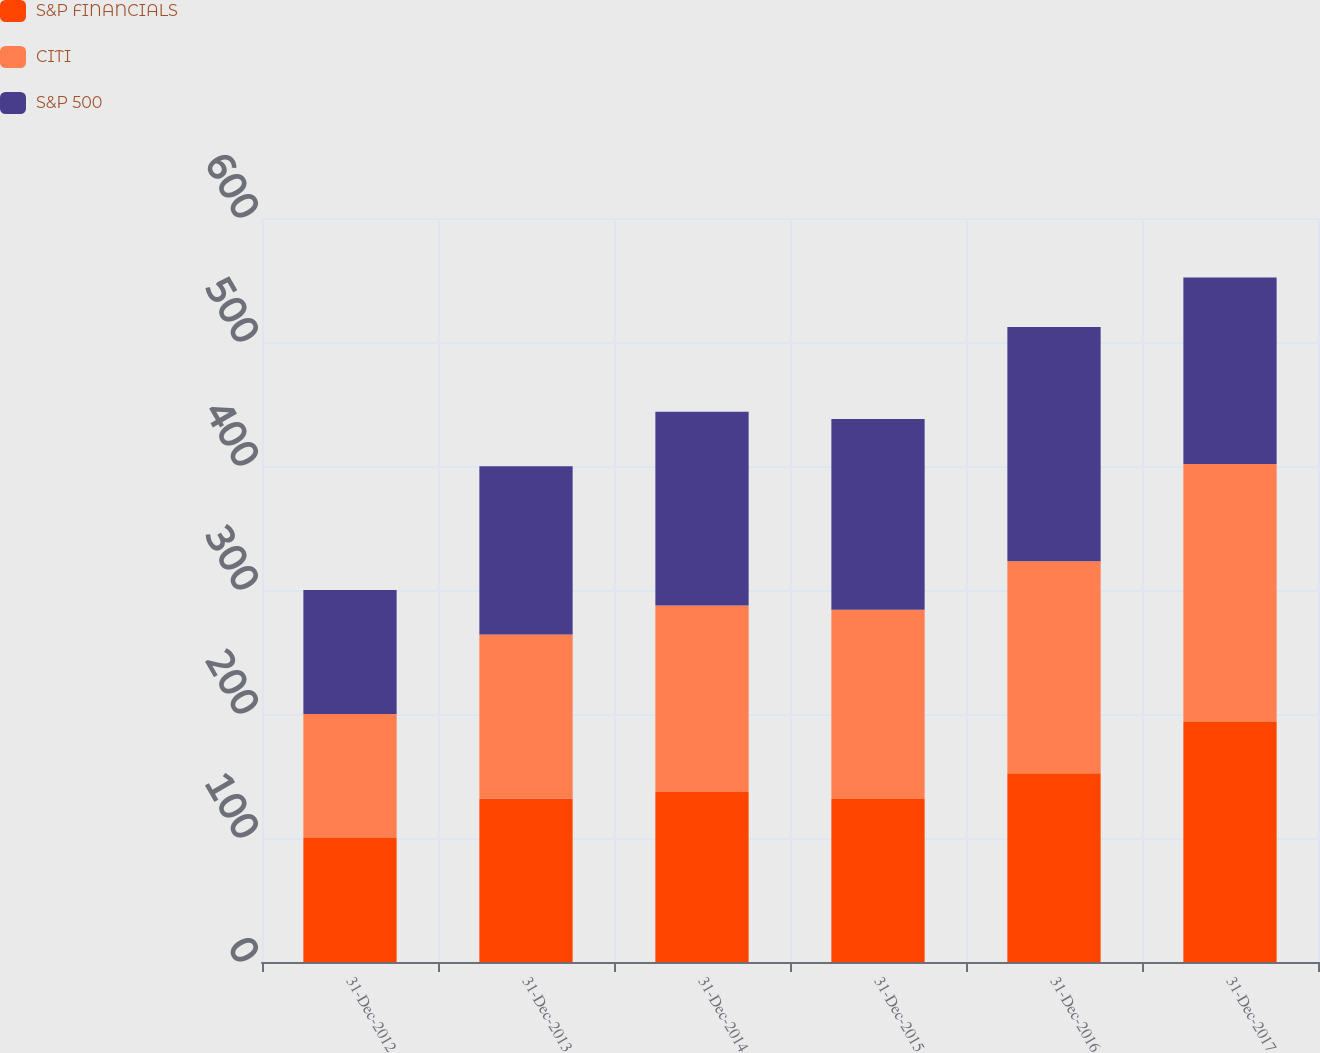Convert chart. <chart><loc_0><loc_0><loc_500><loc_500><stacked_bar_chart><ecel><fcel>31-Dec-2012<fcel>31-Dec-2013<fcel>31-Dec-2014<fcel>31-Dec-2015<fcel>31-Dec-2016<fcel>31-Dec-2017<nl><fcel>S&P FINANCIALS<fcel>100<fcel>131.8<fcel>137<fcel>131.4<fcel>152.3<fcel>193.5<nl><fcel>CITI<fcel>100<fcel>132.4<fcel>150.5<fcel>152.6<fcel>170.8<fcel>208.1<nl><fcel>S&P 500<fcel>100<fcel>135.6<fcel>156.2<fcel>153.9<fcel>188.9<fcel>150.5<nl></chart> 